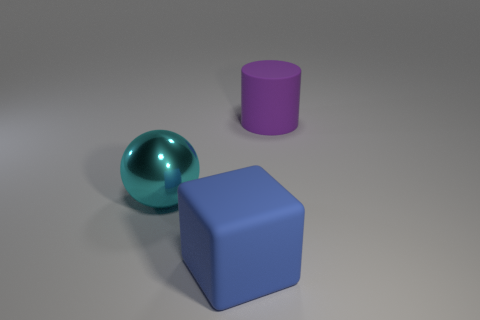Add 1 matte blocks. How many objects exist? 4 Subtract all cubes. How many objects are left? 2 Add 3 rubber spheres. How many rubber spheres exist? 3 Subtract 0 red cubes. How many objects are left? 3 Subtract all big shiny balls. Subtract all large cylinders. How many objects are left? 1 Add 3 large cyan metallic spheres. How many large cyan metallic spheres are left? 4 